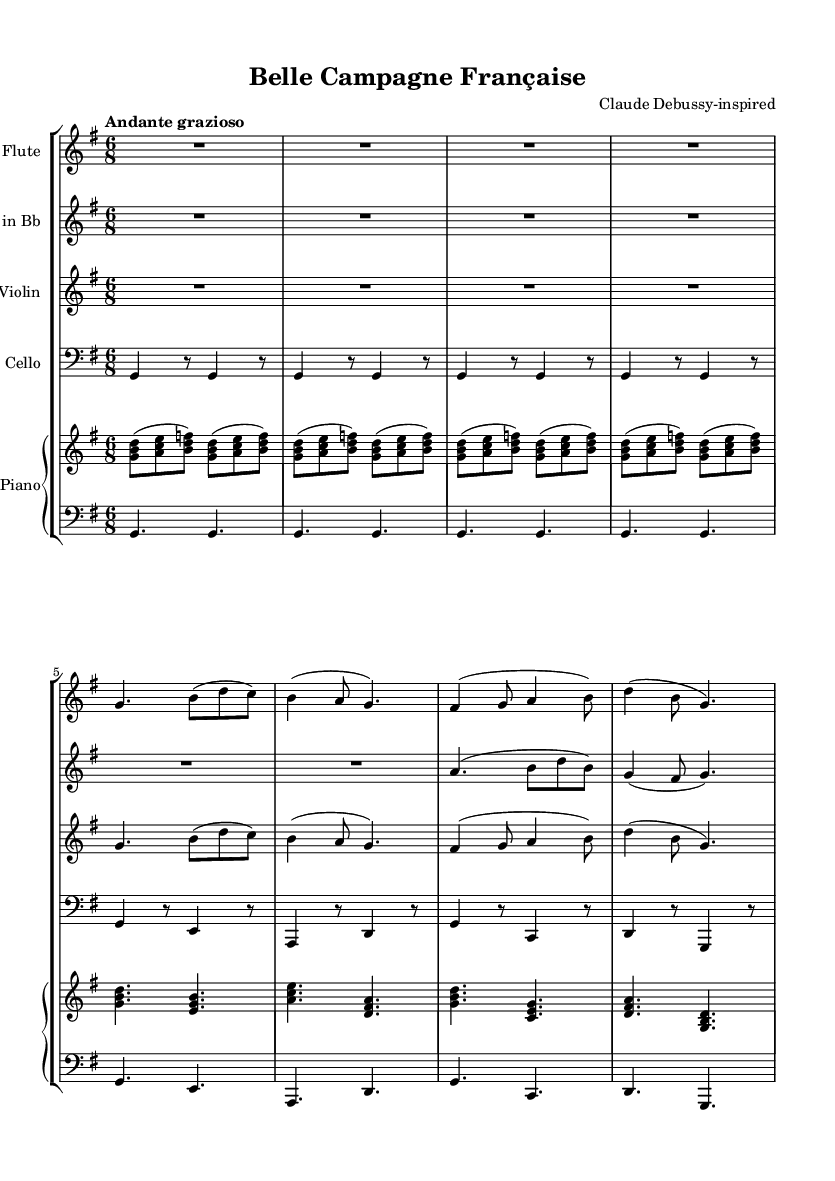What is the key signature of this music? The key signature is G major, which has one sharp. This is determined by looking at the key signature indicator at the beginning of the staff, which shows an F sharp.
Answer: G major What is the time signature of this music? The time signature is 6/8, indicated at the beginning of the score. This tells us there are six eighth notes per measure, giving the piece a lively, compound feel.
Answer: 6/8 What is the tempo marking for this piece? The tempo marking is "Andante grazioso," found at the beginning of the score. This indicates a moderately slow tempo with grace.
Answer: Andante grazioso How many measures are in the flute part? The flute part consists of eight measures, which can be counted by analyzing the staff and tallying each complete measure.
Answer: Eight Which instruments are included in this chamber music ensemble? The ensemble includes Flute, Clarinet in Bb, Violin, Cello, and Piano. This can be determined by looking at the StaffGroup and identifying each instrument labeled before its respective part.
Answer: Flute, Clarinet in Bb, Violin, Cello, Piano What type of musical form could you associate with a piece like this? The music evokes a typical ABA form, which is common in Romantic chamber music by returning to a principal theme after a contrasting section. This can be inferred from the repetition of melodic ideas in the sections.
Answer: ABA form 